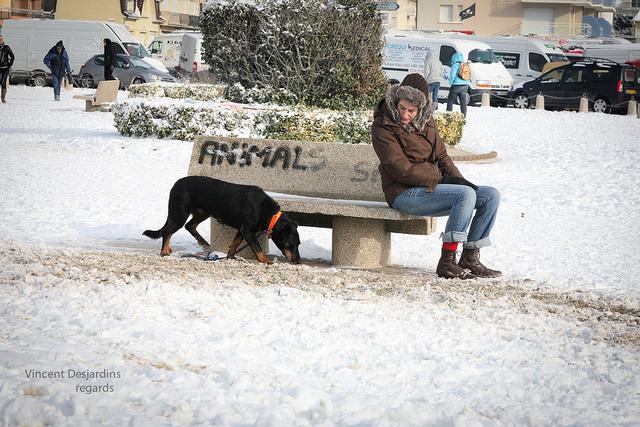What kind of shoe is the person wearing?
Quick response, please. Boots. What breed is the dog?
Answer briefly. Doberman. Does the dog want to go for a walk?
Write a very short answer. No. Can the dog run away?
Concise answer only. Yes. What is written on the bench?
Concise answer only. Animals. 